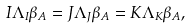Convert formula to latex. <formula><loc_0><loc_0><loc_500><loc_500>I \Lambda _ { I } \beta _ { A } = J \Lambda _ { J } \beta _ { A } = K \Lambda _ { K } \beta _ { A } ,</formula> 